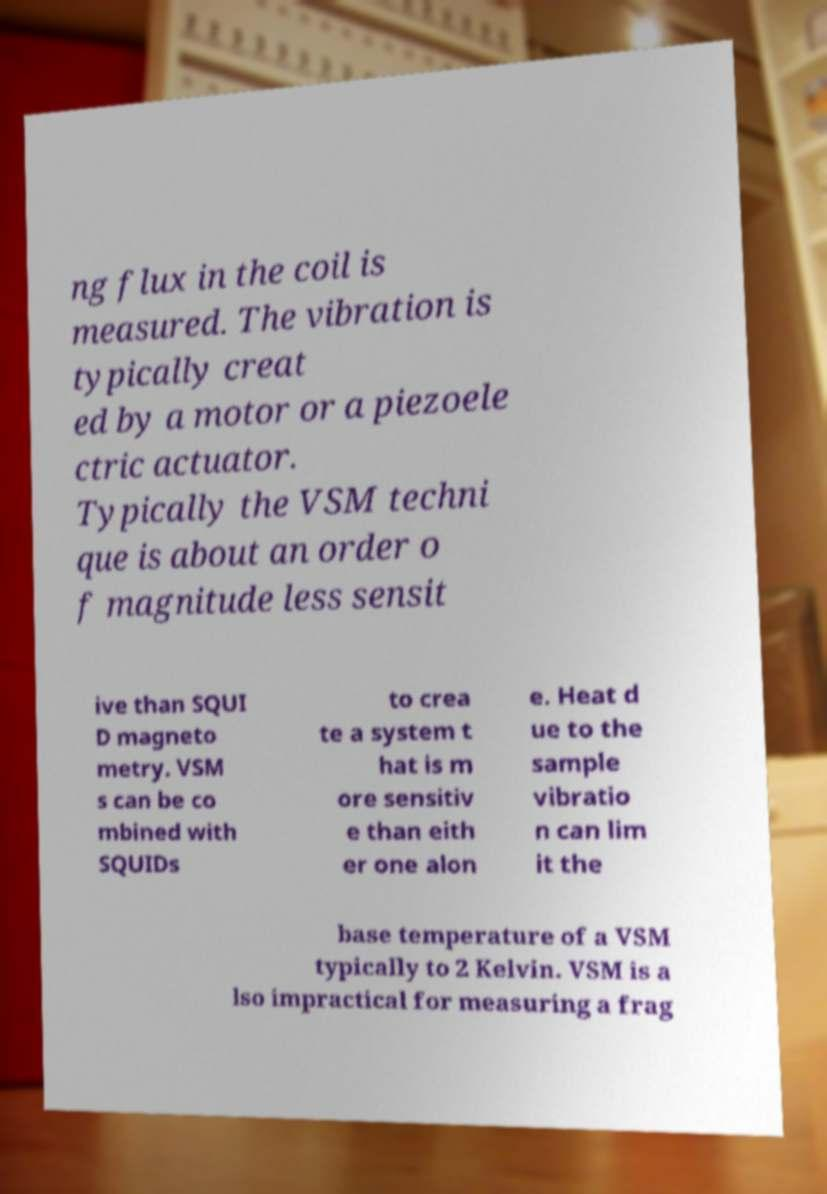What messages or text are displayed in this image? I need them in a readable, typed format. ng flux in the coil is measured. The vibration is typically creat ed by a motor or a piezoele ctric actuator. Typically the VSM techni que is about an order o f magnitude less sensit ive than SQUI D magneto metry. VSM s can be co mbined with SQUIDs to crea te a system t hat is m ore sensitiv e than eith er one alon e. Heat d ue to the sample vibratio n can lim it the base temperature of a VSM typically to 2 Kelvin. VSM is a lso impractical for measuring a frag 